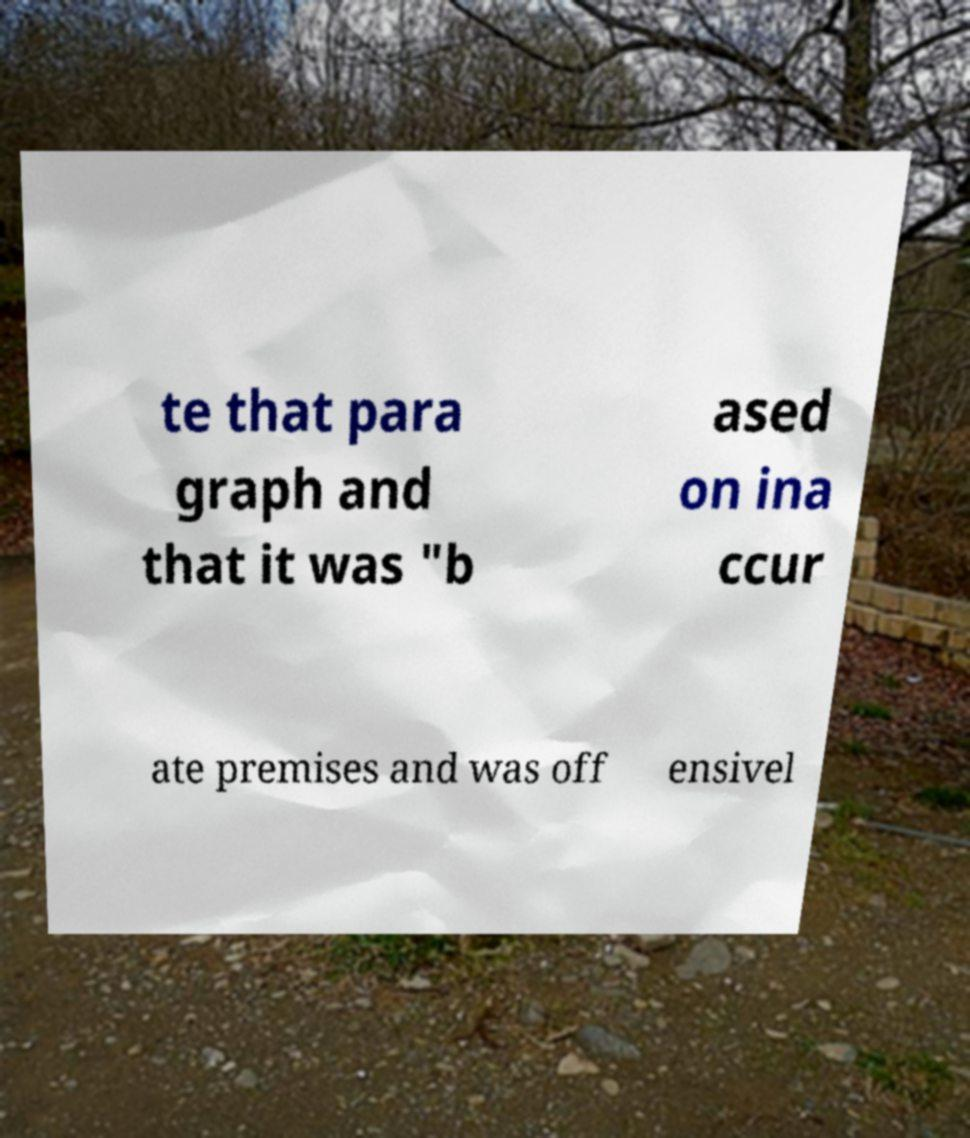I need the written content from this picture converted into text. Can you do that? te that para graph and that it was "b ased on ina ccur ate premises and was off ensivel 